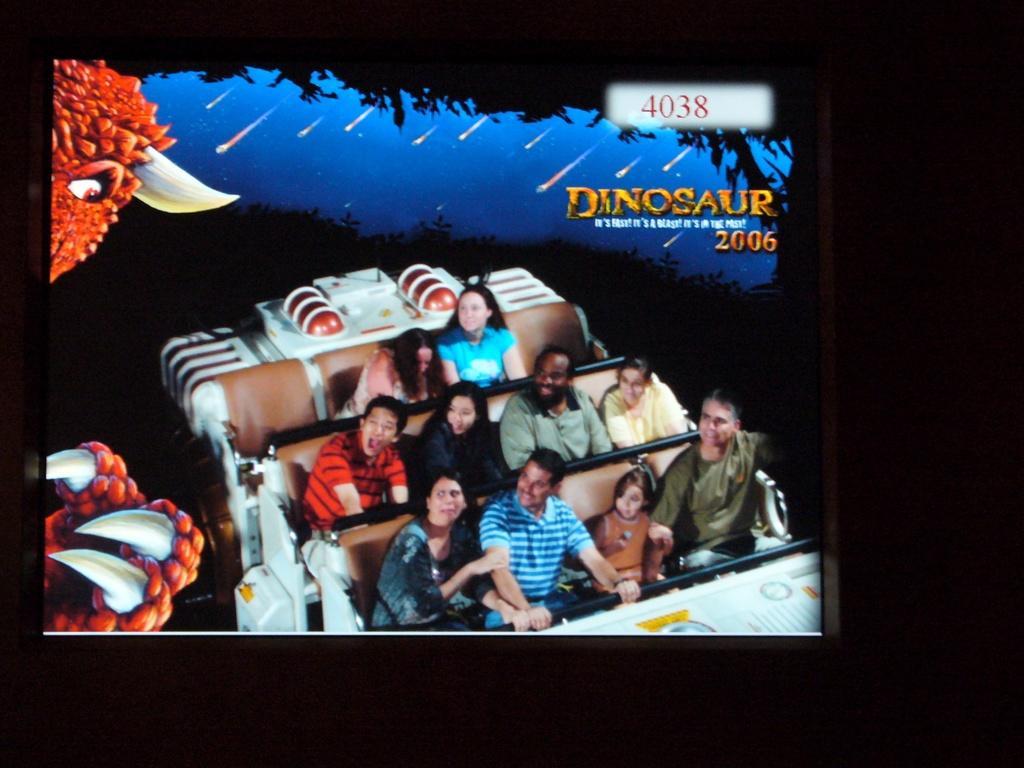Please provide a concise description of this image. In this picture there is a rollercoaster and the group of people are sitting on it. Towards the bottom there are four people in the one seat, four people in another seat and two people in the last seat. Towards the bottom left there is a hand, towards the top left there is a head and a beak. In the picture there is a text towards the top right. 